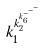<formula> <loc_0><loc_0><loc_500><loc_500>k _ { 1 } ^ { k _ { 2 } ^ { k _ { 6 } ^ { - ^ { - ^ { - } } } } }</formula> 